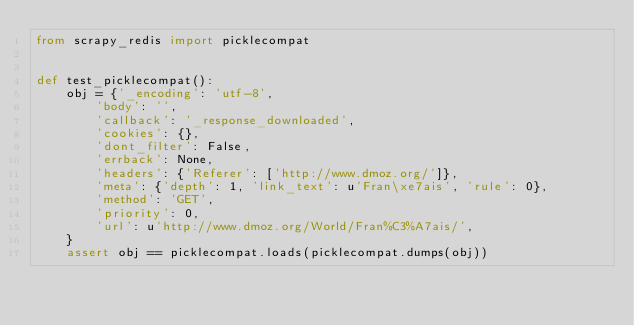<code> <loc_0><loc_0><loc_500><loc_500><_Python_>from scrapy_redis import picklecompat


def test_picklecompat():
    obj = {'_encoding': 'utf-8',
        'body': '',
        'callback': '_response_downloaded',
        'cookies': {},
        'dont_filter': False,
        'errback': None,
        'headers': {'Referer': ['http://www.dmoz.org/']},
        'meta': {'depth': 1, 'link_text': u'Fran\xe7ais', 'rule': 0},
        'method': 'GET',
        'priority': 0,
        'url': u'http://www.dmoz.org/World/Fran%C3%A7ais/',
    }
    assert obj == picklecompat.loads(picklecompat.dumps(obj))
</code> 